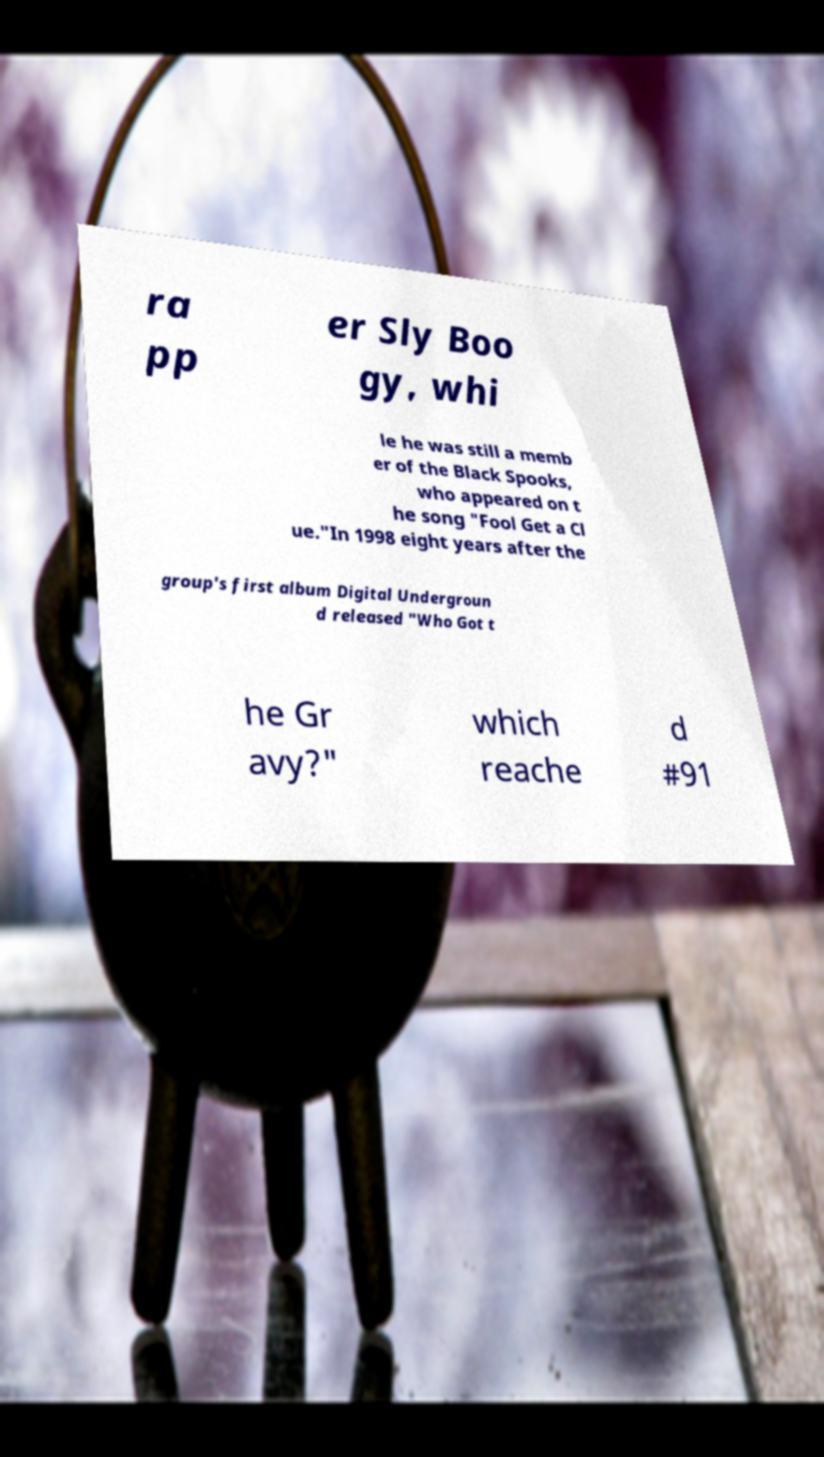Could you extract and type out the text from this image? ra pp er Sly Boo gy, whi le he was still a memb er of the Black Spooks, who appeared on t he song "Fool Get a Cl ue."In 1998 eight years after the group's first album Digital Undergroun d released "Who Got t he Gr avy?" which reache d #91 